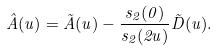<formula> <loc_0><loc_0><loc_500><loc_500>\hat { A } ( u ) = \tilde { A } ( u ) - \frac { s _ { 2 } ( 0 ) } { s _ { 2 } ( 2 u ) } \tilde { D } ( u ) .</formula> 